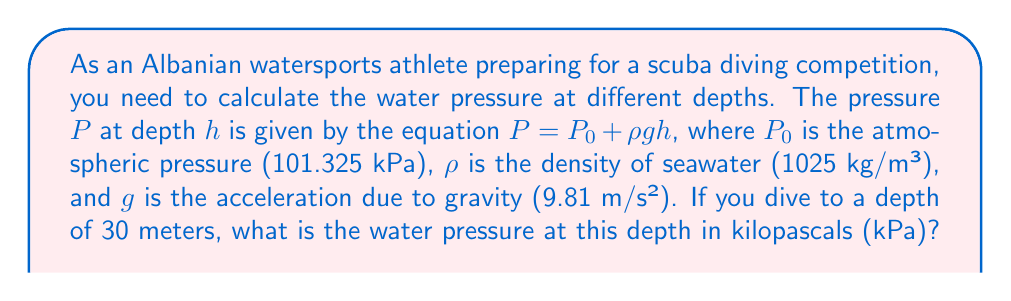Help me with this question. To solve this problem, we'll use the given equation and substitute the known values:

$P = P_0 + \rho gh$

Where:
$P_0 = 101.325$ kPa (atmospheric pressure)
$\rho = 1025$ kg/m³ (density of seawater)
$g = 9.81$ m/s² (acceleration due to gravity)
$h = 30$ m (depth)

Let's substitute these values into the equation:

$P = 101.325 + (1025 \times 9.81 \times 30)$

First, let's calculate the product inside the parentheses:
$1025 \times 9.81 \times 30 = 301,557.5$

Now, we can add this to the atmospheric pressure:
$P = 101.325 + 301.557.5 = 402,882.5$ Pa

Since the question asks for the pressure in kilopascals (kPa), we need to divide by 1000:

$P = 402,882.5 \div 1000 = 402.8825$ kPa

Rounding to two decimal places, we get the final answer.
Answer: $402.88$ kPa 